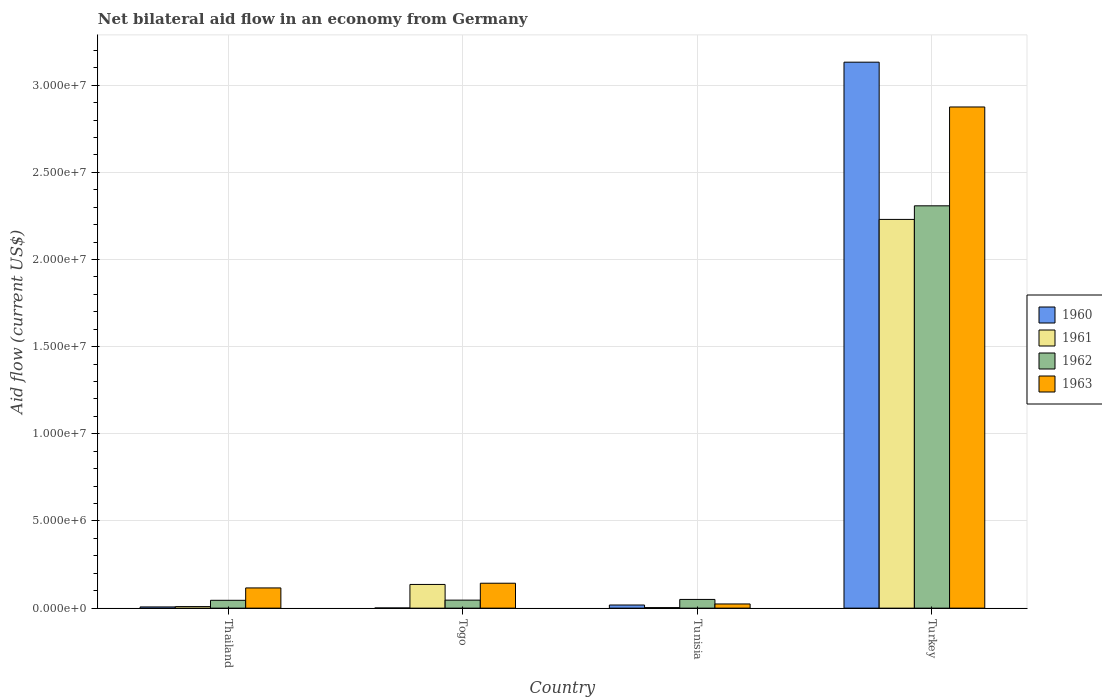Are the number of bars per tick equal to the number of legend labels?
Offer a very short reply. Yes. How many bars are there on the 1st tick from the left?
Offer a terse response. 4. How many bars are there on the 1st tick from the right?
Your answer should be compact. 4. What is the label of the 4th group of bars from the left?
Keep it short and to the point. Turkey. In how many cases, is the number of bars for a given country not equal to the number of legend labels?
Your answer should be compact. 0. What is the net bilateral aid flow in 1961 in Tunisia?
Keep it short and to the point. 3.00e+04. Across all countries, what is the maximum net bilateral aid flow in 1960?
Your answer should be compact. 3.13e+07. In which country was the net bilateral aid flow in 1961 minimum?
Your answer should be very brief. Tunisia. What is the total net bilateral aid flow in 1960 in the graph?
Provide a succinct answer. 3.16e+07. What is the difference between the net bilateral aid flow in 1963 in Tunisia and that in Turkey?
Ensure brevity in your answer.  -2.85e+07. What is the difference between the net bilateral aid flow in 1961 in Turkey and the net bilateral aid flow in 1962 in Thailand?
Provide a succinct answer. 2.18e+07. What is the average net bilateral aid flow in 1961 per country?
Your answer should be compact. 5.94e+06. What is the ratio of the net bilateral aid flow in 1963 in Togo to that in Turkey?
Your response must be concise. 0.05. Is the net bilateral aid flow in 1960 in Tunisia less than that in Turkey?
Provide a succinct answer. Yes. Is the difference between the net bilateral aid flow in 1960 in Thailand and Turkey greater than the difference between the net bilateral aid flow in 1963 in Thailand and Turkey?
Provide a short and direct response. No. What is the difference between the highest and the second highest net bilateral aid flow in 1961?
Your answer should be very brief. 2.22e+07. What is the difference between the highest and the lowest net bilateral aid flow in 1960?
Your answer should be compact. 3.13e+07. Is the sum of the net bilateral aid flow in 1962 in Thailand and Tunisia greater than the maximum net bilateral aid flow in 1961 across all countries?
Your answer should be compact. No. Is it the case that in every country, the sum of the net bilateral aid flow in 1963 and net bilateral aid flow in 1962 is greater than the sum of net bilateral aid flow in 1961 and net bilateral aid flow in 1960?
Your response must be concise. No. What does the 3rd bar from the left in Togo represents?
Offer a very short reply. 1962. Is it the case that in every country, the sum of the net bilateral aid flow in 1962 and net bilateral aid flow in 1960 is greater than the net bilateral aid flow in 1963?
Offer a terse response. No. Are all the bars in the graph horizontal?
Provide a short and direct response. No. What is the difference between two consecutive major ticks on the Y-axis?
Make the answer very short. 5.00e+06. Are the values on the major ticks of Y-axis written in scientific E-notation?
Make the answer very short. Yes. Does the graph contain grids?
Offer a very short reply. Yes. What is the title of the graph?
Your response must be concise. Net bilateral aid flow in an economy from Germany. Does "1969" appear as one of the legend labels in the graph?
Make the answer very short. No. What is the Aid flow (current US$) of 1960 in Thailand?
Your answer should be compact. 7.00e+04. What is the Aid flow (current US$) of 1962 in Thailand?
Provide a short and direct response. 4.50e+05. What is the Aid flow (current US$) of 1963 in Thailand?
Ensure brevity in your answer.  1.16e+06. What is the Aid flow (current US$) in 1961 in Togo?
Offer a very short reply. 1.36e+06. What is the Aid flow (current US$) in 1962 in Togo?
Your response must be concise. 4.60e+05. What is the Aid flow (current US$) of 1963 in Togo?
Offer a very short reply. 1.43e+06. What is the Aid flow (current US$) of 1963 in Tunisia?
Make the answer very short. 2.40e+05. What is the Aid flow (current US$) in 1960 in Turkey?
Keep it short and to the point. 3.13e+07. What is the Aid flow (current US$) of 1961 in Turkey?
Your answer should be compact. 2.23e+07. What is the Aid flow (current US$) of 1962 in Turkey?
Your answer should be very brief. 2.31e+07. What is the Aid flow (current US$) of 1963 in Turkey?
Provide a succinct answer. 2.88e+07. Across all countries, what is the maximum Aid flow (current US$) in 1960?
Make the answer very short. 3.13e+07. Across all countries, what is the maximum Aid flow (current US$) of 1961?
Give a very brief answer. 2.23e+07. Across all countries, what is the maximum Aid flow (current US$) in 1962?
Provide a succinct answer. 2.31e+07. Across all countries, what is the maximum Aid flow (current US$) in 1963?
Make the answer very short. 2.88e+07. Across all countries, what is the minimum Aid flow (current US$) of 1962?
Keep it short and to the point. 4.50e+05. What is the total Aid flow (current US$) in 1960 in the graph?
Offer a terse response. 3.16e+07. What is the total Aid flow (current US$) of 1961 in the graph?
Give a very brief answer. 2.38e+07. What is the total Aid flow (current US$) of 1962 in the graph?
Keep it short and to the point. 2.45e+07. What is the total Aid flow (current US$) of 1963 in the graph?
Keep it short and to the point. 3.16e+07. What is the difference between the Aid flow (current US$) in 1961 in Thailand and that in Togo?
Your response must be concise. -1.27e+06. What is the difference between the Aid flow (current US$) of 1960 in Thailand and that in Tunisia?
Provide a short and direct response. -1.10e+05. What is the difference between the Aid flow (current US$) of 1963 in Thailand and that in Tunisia?
Your answer should be compact. 9.20e+05. What is the difference between the Aid flow (current US$) in 1960 in Thailand and that in Turkey?
Offer a very short reply. -3.12e+07. What is the difference between the Aid flow (current US$) of 1961 in Thailand and that in Turkey?
Provide a short and direct response. -2.22e+07. What is the difference between the Aid flow (current US$) in 1962 in Thailand and that in Turkey?
Make the answer very short. -2.26e+07. What is the difference between the Aid flow (current US$) of 1963 in Thailand and that in Turkey?
Provide a succinct answer. -2.76e+07. What is the difference between the Aid flow (current US$) of 1960 in Togo and that in Tunisia?
Give a very brief answer. -1.70e+05. What is the difference between the Aid flow (current US$) of 1961 in Togo and that in Tunisia?
Your answer should be compact. 1.33e+06. What is the difference between the Aid flow (current US$) of 1963 in Togo and that in Tunisia?
Your response must be concise. 1.19e+06. What is the difference between the Aid flow (current US$) of 1960 in Togo and that in Turkey?
Offer a terse response. -3.13e+07. What is the difference between the Aid flow (current US$) of 1961 in Togo and that in Turkey?
Offer a terse response. -2.09e+07. What is the difference between the Aid flow (current US$) in 1962 in Togo and that in Turkey?
Your answer should be compact. -2.26e+07. What is the difference between the Aid flow (current US$) in 1963 in Togo and that in Turkey?
Ensure brevity in your answer.  -2.73e+07. What is the difference between the Aid flow (current US$) in 1960 in Tunisia and that in Turkey?
Provide a succinct answer. -3.11e+07. What is the difference between the Aid flow (current US$) in 1961 in Tunisia and that in Turkey?
Offer a very short reply. -2.23e+07. What is the difference between the Aid flow (current US$) of 1962 in Tunisia and that in Turkey?
Ensure brevity in your answer.  -2.26e+07. What is the difference between the Aid flow (current US$) of 1963 in Tunisia and that in Turkey?
Your response must be concise. -2.85e+07. What is the difference between the Aid flow (current US$) of 1960 in Thailand and the Aid flow (current US$) of 1961 in Togo?
Provide a short and direct response. -1.29e+06. What is the difference between the Aid flow (current US$) in 1960 in Thailand and the Aid flow (current US$) in 1962 in Togo?
Your answer should be very brief. -3.90e+05. What is the difference between the Aid flow (current US$) of 1960 in Thailand and the Aid flow (current US$) of 1963 in Togo?
Offer a very short reply. -1.36e+06. What is the difference between the Aid flow (current US$) in 1961 in Thailand and the Aid flow (current US$) in 1962 in Togo?
Your response must be concise. -3.70e+05. What is the difference between the Aid flow (current US$) of 1961 in Thailand and the Aid flow (current US$) of 1963 in Togo?
Keep it short and to the point. -1.34e+06. What is the difference between the Aid flow (current US$) in 1962 in Thailand and the Aid flow (current US$) in 1963 in Togo?
Keep it short and to the point. -9.80e+05. What is the difference between the Aid flow (current US$) in 1960 in Thailand and the Aid flow (current US$) in 1962 in Tunisia?
Make the answer very short. -4.30e+05. What is the difference between the Aid flow (current US$) in 1961 in Thailand and the Aid flow (current US$) in 1962 in Tunisia?
Provide a succinct answer. -4.10e+05. What is the difference between the Aid flow (current US$) in 1961 in Thailand and the Aid flow (current US$) in 1963 in Tunisia?
Offer a terse response. -1.50e+05. What is the difference between the Aid flow (current US$) of 1960 in Thailand and the Aid flow (current US$) of 1961 in Turkey?
Make the answer very short. -2.22e+07. What is the difference between the Aid flow (current US$) in 1960 in Thailand and the Aid flow (current US$) in 1962 in Turkey?
Offer a terse response. -2.30e+07. What is the difference between the Aid flow (current US$) in 1960 in Thailand and the Aid flow (current US$) in 1963 in Turkey?
Your response must be concise. -2.87e+07. What is the difference between the Aid flow (current US$) of 1961 in Thailand and the Aid flow (current US$) of 1962 in Turkey?
Keep it short and to the point. -2.30e+07. What is the difference between the Aid flow (current US$) in 1961 in Thailand and the Aid flow (current US$) in 1963 in Turkey?
Keep it short and to the point. -2.87e+07. What is the difference between the Aid flow (current US$) in 1962 in Thailand and the Aid flow (current US$) in 1963 in Turkey?
Offer a very short reply. -2.83e+07. What is the difference between the Aid flow (current US$) in 1960 in Togo and the Aid flow (current US$) in 1961 in Tunisia?
Offer a terse response. -2.00e+04. What is the difference between the Aid flow (current US$) in 1960 in Togo and the Aid flow (current US$) in 1962 in Tunisia?
Make the answer very short. -4.90e+05. What is the difference between the Aid flow (current US$) in 1961 in Togo and the Aid flow (current US$) in 1962 in Tunisia?
Make the answer very short. 8.60e+05. What is the difference between the Aid flow (current US$) in 1961 in Togo and the Aid flow (current US$) in 1963 in Tunisia?
Offer a very short reply. 1.12e+06. What is the difference between the Aid flow (current US$) of 1962 in Togo and the Aid flow (current US$) of 1963 in Tunisia?
Your response must be concise. 2.20e+05. What is the difference between the Aid flow (current US$) in 1960 in Togo and the Aid flow (current US$) in 1961 in Turkey?
Offer a terse response. -2.23e+07. What is the difference between the Aid flow (current US$) in 1960 in Togo and the Aid flow (current US$) in 1962 in Turkey?
Make the answer very short. -2.31e+07. What is the difference between the Aid flow (current US$) in 1960 in Togo and the Aid flow (current US$) in 1963 in Turkey?
Offer a very short reply. -2.87e+07. What is the difference between the Aid flow (current US$) of 1961 in Togo and the Aid flow (current US$) of 1962 in Turkey?
Your response must be concise. -2.17e+07. What is the difference between the Aid flow (current US$) of 1961 in Togo and the Aid flow (current US$) of 1963 in Turkey?
Give a very brief answer. -2.74e+07. What is the difference between the Aid flow (current US$) in 1962 in Togo and the Aid flow (current US$) in 1963 in Turkey?
Your response must be concise. -2.83e+07. What is the difference between the Aid flow (current US$) in 1960 in Tunisia and the Aid flow (current US$) in 1961 in Turkey?
Ensure brevity in your answer.  -2.21e+07. What is the difference between the Aid flow (current US$) of 1960 in Tunisia and the Aid flow (current US$) of 1962 in Turkey?
Make the answer very short. -2.29e+07. What is the difference between the Aid flow (current US$) of 1960 in Tunisia and the Aid flow (current US$) of 1963 in Turkey?
Your answer should be very brief. -2.86e+07. What is the difference between the Aid flow (current US$) of 1961 in Tunisia and the Aid flow (current US$) of 1962 in Turkey?
Give a very brief answer. -2.30e+07. What is the difference between the Aid flow (current US$) in 1961 in Tunisia and the Aid flow (current US$) in 1963 in Turkey?
Offer a very short reply. -2.87e+07. What is the difference between the Aid flow (current US$) of 1962 in Tunisia and the Aid flow (current US$) of 1963 in Turkey?
Your answer should be very brief. -2.82e+07. What is the average Aid flow (current US$) of 1960 per country?
Give a very brief answer. 7.90e+06. What is the average Aid flow (current US$) of 1961 per country?
Your response must be concise. 5.94e+06. What is the average Aid flow (current US$) of 1962 per country?
Your response must be concise. 6.12e+06. What is the average Aid flow (current US$) of 1963 per country?
Ensure brevity in your answer.  7.90e+06. What is the difference between the Aid flow (current US$) in 1960 and Aid flow (current US$) in 1961 in Thailand?
Your answer should be compact. -2.00e+04. What is the difference between the Aid flow (current US$) in 1960 and Aid flow (current US$) in 1962 in Thailand?
Your response must be concise. -3.80e+05. What is the difference between the Aid flow (current US$) in 1960 and Aid flow (current US$) in 1963 in Thailand?
Your answer should be very brief. -1.09e+06. What is the difference between the Aid flow (current US$) in 1961 and Aid flow (current US$) in 1962 in Thailand?
Your response must be concise. -3.60e+05. What is the difference between the Aid flow (current US$) in 1961 and Aid flow (current US$) in 1963 in Thailand?
Provide a succinct answer. -1.07e+06. What is the difference between the Aid flow (current US$) of 1962 and Aid flow (current US$) of 1963 in Thailand?
Make the answer very short. -7.10e+05. What is the difference between the Aid flow (current US$) in 1960 and Aid flow (current US$) in 1961 in Togo?
Provide a succinct answer. -1.35e+06. What is the difference between the Aid flow (current US$) in 1960 and Aid flow (current US$) in 1962 in Togo?
Offer a very short reply. -4.50e+05. What is the difference between the Aid flow (current US$) of 1960 and Aid flow (current US$) of 1963 in Togo?
Provide a short and direct response. -1.42e+06. What is the difference between the Aid flow (current US$) of 1962 and Aid flow (current US$) of 1963 in Togo?
Provide a short and direct response. -9.70e+05. What is the difference between the Aid flow (current US$) of 1960 and Aid flow (current US$) of 1961 in Tunisia?
Offer a very short reply. 1.50e+05. What is the difference between the Aid flow (current US$) of 1960 and Aid flow (current US$) of 1962 in Tunisia?
Your answer should be compact. -3.20e+05. What is the difference between the Aid flow (current US$) of 1960 and Aid flow (current US$) of 1963 in Tunisia?
Offer a terse response. -6.00e+04. What is the difference between the Aid flow (current US$) of 1961 and Aid flow (current US$) of 1962 in Tunisia?
Offer a terse response. -4.70e+05. What is the difference between the Aid flow (current US$) of 1961 and Aid flow (current US$) of 1963 in Tunisia?
Your answer should be very brief. -2.10e+05. What is the difference between the Aid flow (current US$) of 1962 and Aid flow (current US$) of 1963 in Tunisia?
Provide a succinct answer. 2.60e+05. What is the difference between the Aid flow (current US$) of 1960 and Aid flow (current US$) of 1961 in Turkey?
Your answer should be very brief. 9.02e+06. What is the difference between the Aid flow (current US$) of 1960 and Aid flow (current US$) of 1962 in Turkey?
Give a very brief answer. 8.24e+06. What is the difference between the Aid flow (current US$) of 1960 and Aid flow (current US$) of 1963 in Turkey?
Offer a terse response. 2.57e+06. What is the difference between the Aid flow (current US$) in 1961 and Aid flow (current US$) in 1962 in Turkey?
Provide a succinct answer. -7.80e+05. What is the difference between the Aid flow (current US$) of 1961 and Aid flow (current US$) of 1963 in Turkey?
Your answer should be compact. -6.45e+06. What is the difference between the Aid flow (current US$) in 1962 and Aid flow (current US$) in 1963 in Turkey?
Your answer should be very brief. -5.67e+06. What is the ratio of the Aid flow (current US$) of 1961 in Thailand to that in Togo?
Offer a very short reply. 0.07. What is the ratio of the Aid flow (current US$) of 1962 in Thailand to that in Togo?
Offer a terse response. 0.98. What is the ratio of the Aid flow (current US$) of 1963 in Thailand to that in Togo?
Provide a short and direct response. 0.81. What is the ratio of the Aid flow (current US$) of 1960 in Thailand to that in Tunisia?
Offer a very short reply. 0.39. What is the ratio of the Aid flow (current US$) in 1962 in Thailand to that in Tunisia?
Your answer should be compact. 0.9. What is the ratio of the Aid flow (current US$) in 1963 in Thailand to that in Tunisia?
Offer a terse response. 4.83. What is the ratio of the Aid flow (current US$) of 1960 in Thailand to that in Turkey?
Provide a short and direct response. 0. What is the ratio of the Aid flow (current US$) of 1961 in Thailand to that in Turkey?
Offer a very short reply. 0. What is the ratio of the Aid flow (current US$) of 1962 in Thailand to that in Turkey?
Make the answer very short. 0.02. What is the ratio of the Aid flow (current US$) of 1963 in Thailand to that in Turkey?
Offer a terse response. 0.04. What is the ratio of the Aid flow (current US$) in 1960 in Togo to that in Tunisia?
Your answer should be very brief. 0.06. What is the ratio of the Aid flow (current US$) of 1961 in Togo to that in Tunisia?
Your answer should be very brief. 45.33. What is the ratio of the Aid flow (current US$) of 1963 in Togo to that in Tunisia?
Give a very brief answer. 5.96. What is the ratio of the Aid flow (current US$) in 1960 in Togo to that in Turkey?
Your response must be concise. 0. What is the ratio of the Aid flow (current US$) of 1961 in Togo to that in Turkey?
Your response must be concise. 0.06. What is the ratio of the Aid flow (current US$) in 1962 in Togo to that in Turkey?
Make the answer very short. 0.02. What is the ratio of the Aid flow (current US$) in 1963 in Togo to that in Turkey?
Provide a succinct answer. 0.05. What is the ratio of the Aid flow (current US$) in 1960 in Tunisia to that in Turkey?
Your answer should be compact. 0.01. What is the ratio of the Aid flow (current US$) of 1961 in Tunisia to that in Turkey?
Your answer should be compact. 0. What is the ratio of the Aid flow (current US$) in 1962 in Tunisia to that in Turkey?
Ensure brevity in your answer.  0.02. What is the ratio of the Aid flow (current US$) of 1963 in Tunisia to that in Turkey?
Make the answer very short. 0.01. What is the difference between the highest and the second highest Aid flow (current US$) of 1960?
Offer a terse response. 3.11e+07. What is the difference between the highest and the second highest Aid flow (current US$) in 1961?
Provide a short and direct response. 2.09e+07. What is the difference between the highest and the second highest Aid flow (current US$) of 1962?
Give a very brief answer. 2.26e+07. What is the difference between the highest and the second highest Aid flow (current US$) of 1963?
Offer a terse response. 2.73e+07. What is the difference between the highest and the lowest Aid flow (current US$) of 1960?
Provide a succinct answer. 3.13e+07. What is the difference between the highest and the lowest Aid flow (current US$) in 1961?
Ensure brevity in your answer.  2.23e+07. What is the difference between the highest and the lowest Aid flow (current US$) in 1962?
Your response must be concise. 2.26e+07. What is the difference between the highest and the lowest Aid flow (current US$) in 1963?
Your answer should be very brief. 2.85e+07. 